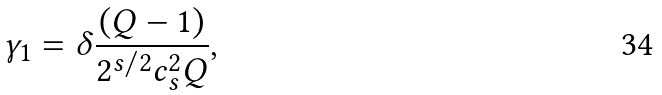<formula> <loc_0><loc_0><loc_500><loc_500>\gamma _ { 1 } = \delta \frac { ( Q - 1 ) } { 2 ^ { s / 2 } c _ { s } ^ { 2 } Q } ,</formula> 